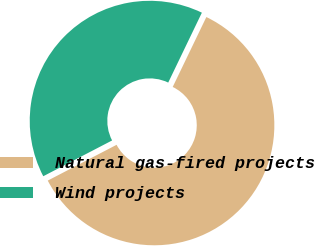Convert chart. <chart><loc_0><loc_0><loc_500><loc_500><pie_chart><fcel>Natural gas-fired projects<fcel>Wind projects<nl><fcel>60.23%<fcel>39.77%<nl></chart> 